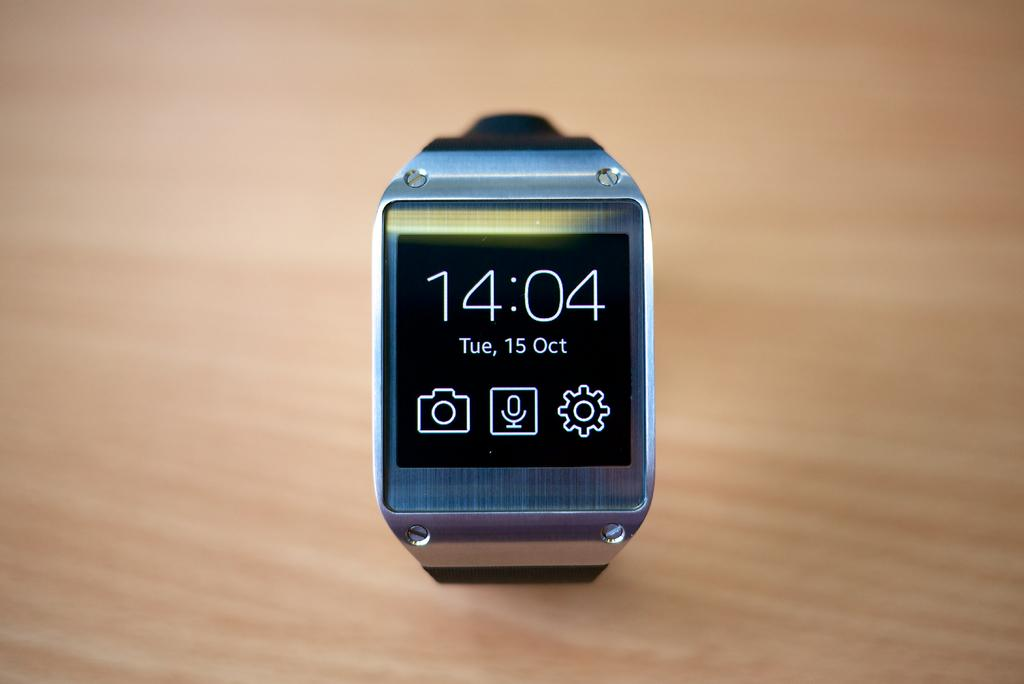<image>
Give a short and clear explanation of the subsequent image. A watch displaying the time of 2:04 and the date of October 15th 